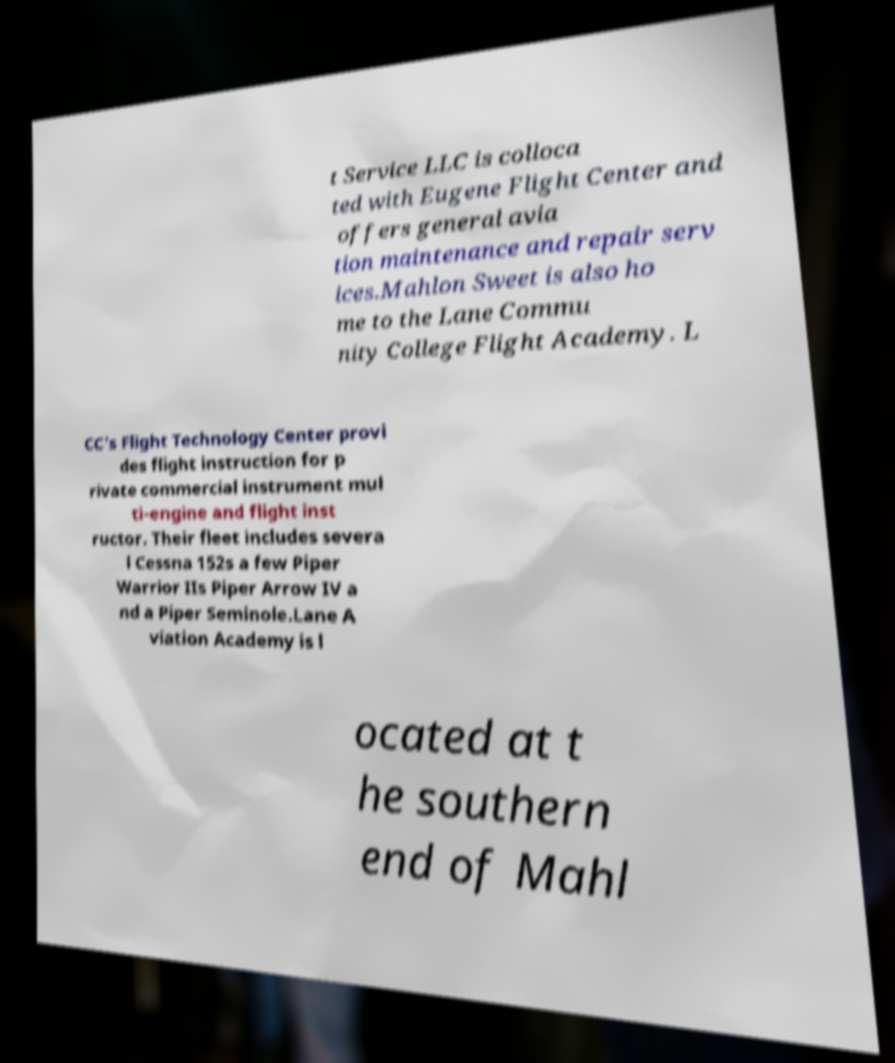Please read and relay the text visible in this image. What does it say? t Service LLC is colloca ted with Eugene Flight Center and offers general avia tion maintenance and repair serv ices.Mahlon Sweet is also ho me to the Lane Commu nity College Flight Academy. L CC's Flight Technology Center provi des flight instruction for p rivate commercial instrument mul ti-engine and flight inst ructor. Their fleet includes severa l Cessna 152s a few Piper Warrior IIs Piper Arrow IV a nd a Piper Seminole.Lane A viation Academy is l ocated at t he southern end of Mahl 